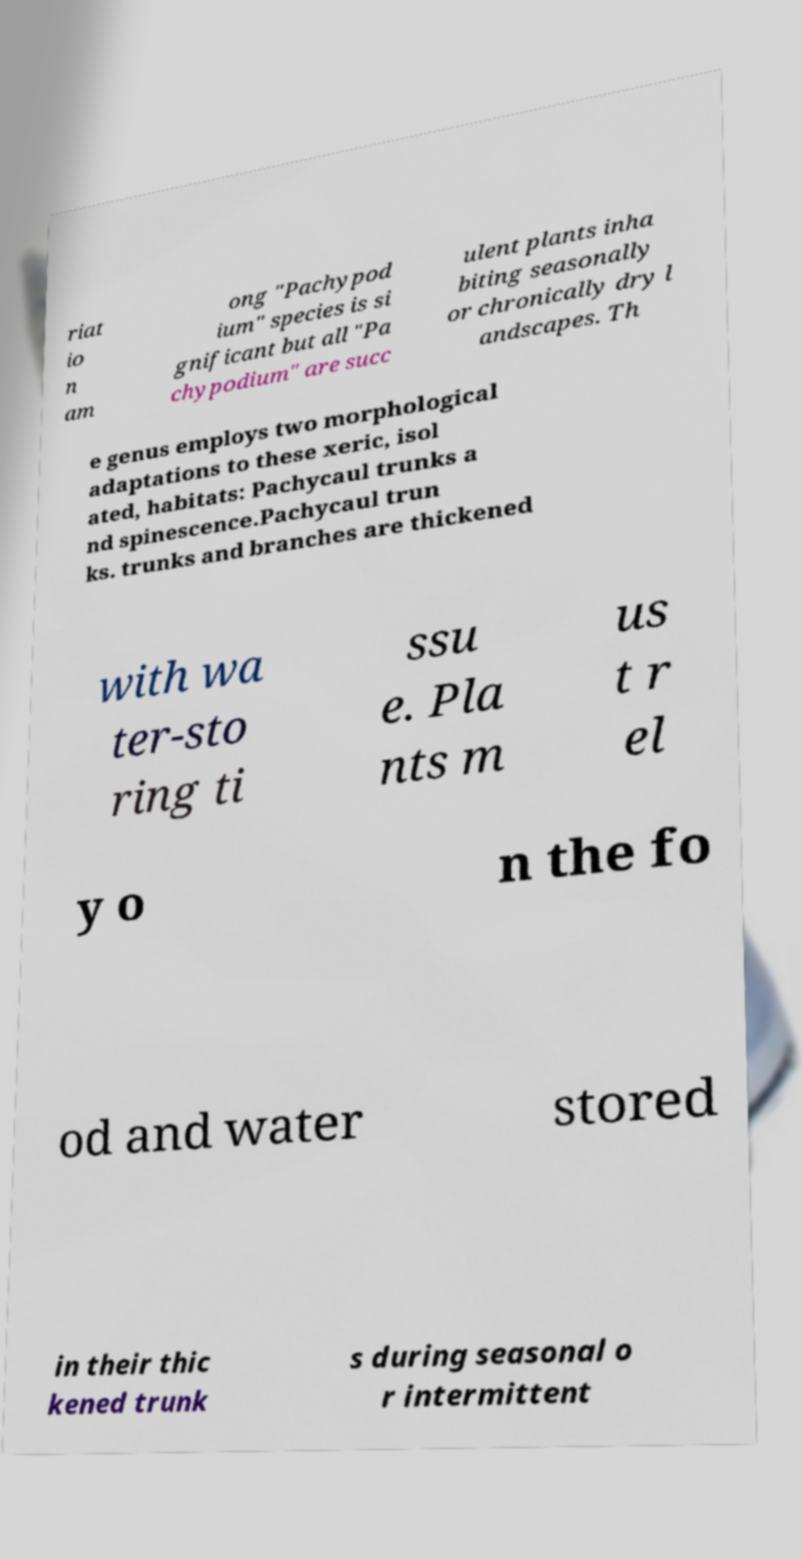For documentation purposes, I need the text within this image transcribed. Could you provide that? riat io n am ong "Pachypod ium" species is si gnificant but all "Pa chypodium" are succ ulent plants inha biting seasonally or chronically dry l andscapes. Th e genus employs two morphological adaptations to these xeric, isol ated, habitats: Pachycaul trunks a nd spinescence.Pachycaul trun ks. trunks and branches are thickened with wa ter-sto ring ti ssu e. Pla nts m us t r el y o n the fo od and water stored in their thic kened trunk s during seasonal o r intermittent 